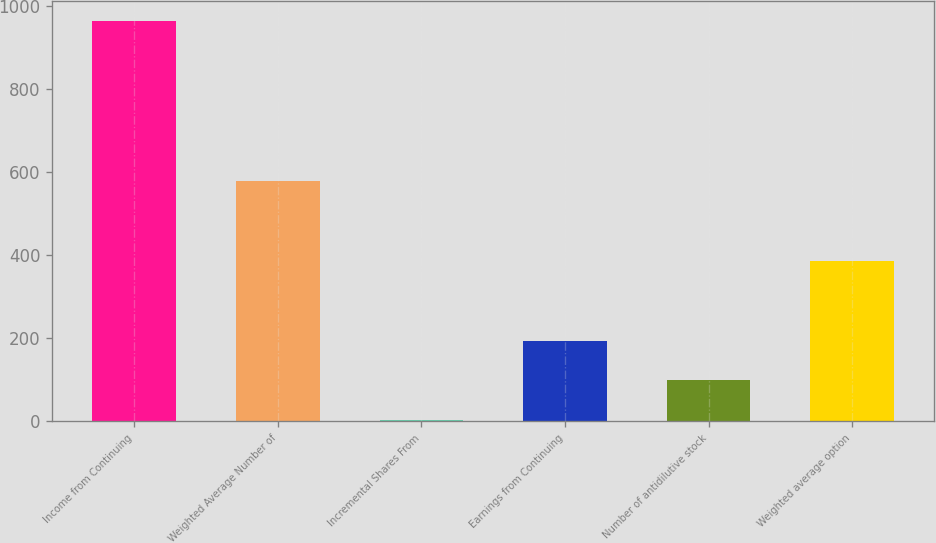Convert chart. <chart><loc_0><loc_0><loc_500><loc_500><bar_chart><fcel>Income from Continuing<fcel>Weighted Average Number of<fcel>Incremental Shares From<fcel>Earnings from Continuing<fcel>Number of antidilutive stock<fcel>Weighted average option<nl><fcel>965<fcel>579.8<fcel>2<fcel>194.6<fcel>98.3<fcel>387.2<nl></chart> 